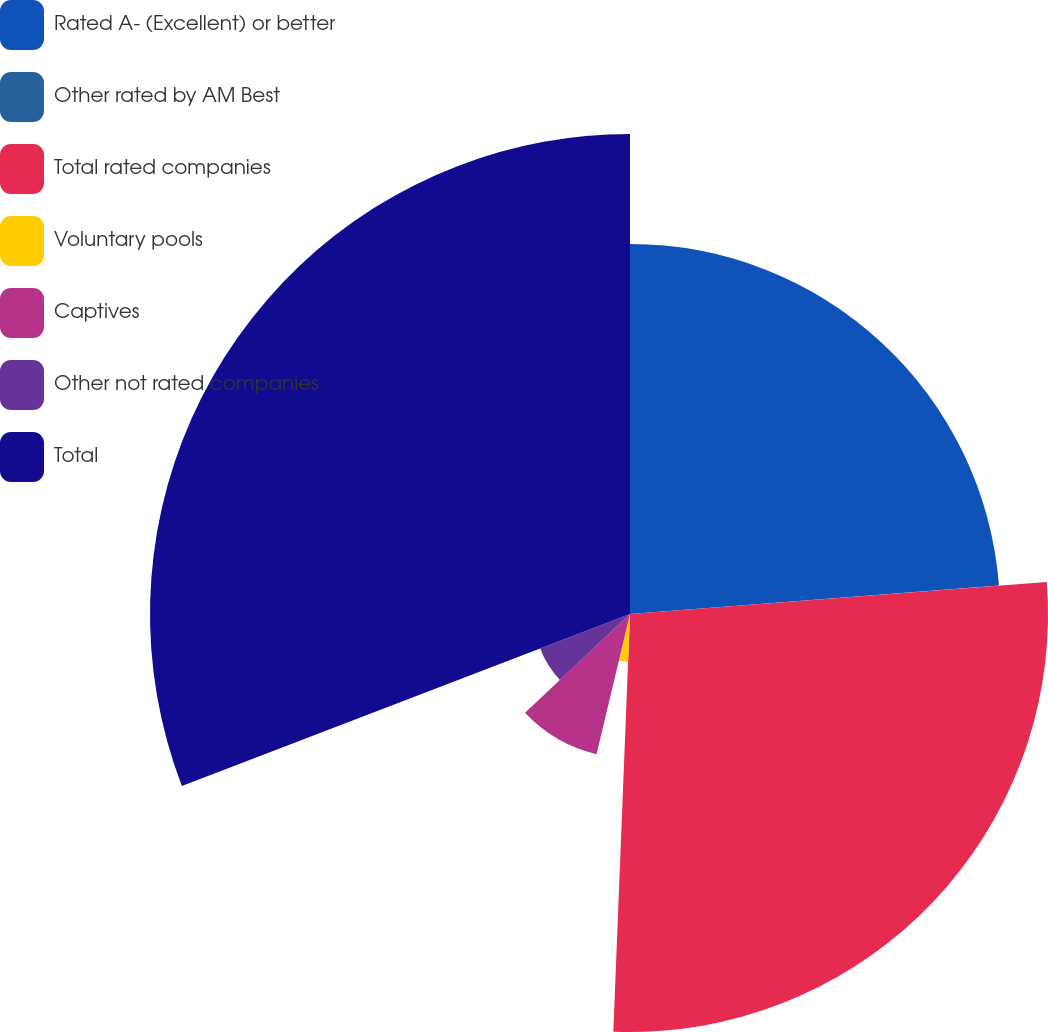Convert chart to OTSL. <chart><loc_0><loc_0><loc_500><loc_500><pie_chart><fcel>Rated A- (Excellent) or better<fcel>Other rated by AM Best<fcel>Total rated companies<fcel>Voluntary pools<fcel>Captives<fcel>Other not rated companies<fcel>Total<nl><fcel>23.77%<fcel>0.01%<fcel>26.85%<fcel>3.09%<fcel>9.26%<fcel>6.18%<fcel>30.83%<nl></chart> 